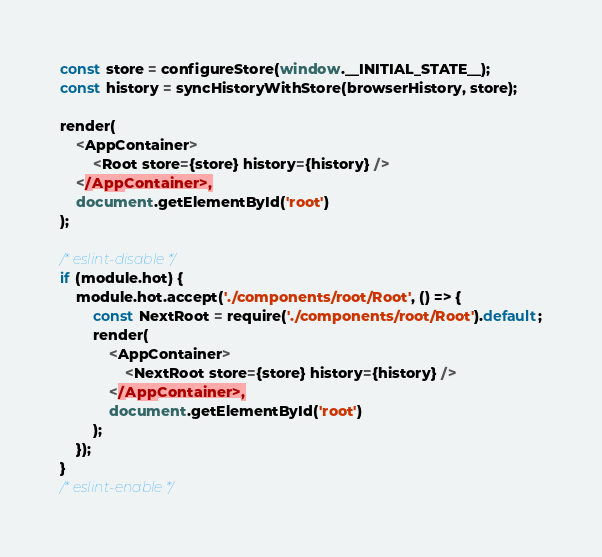Convert code to text. <code><loc_0><loc_0><loc_500><loc_500><_JavaScript_>const store = configureStore(window.__INITIAL_STATE__);
const history = syncHistoryWithStore(browserHistory, store);

render(
    <AppContainer>
        <Root store={store} history={history} />
    </AppContainer>,
    document.getElementById('root')
);

/* eslint-disable */
if (module.hot) {
    module.hot.accept('./components/root/Root', () => {
        const NextRoot = require('./components/root/Root').default;
        render(
            <AppContainer>
                <NextRoot store={store} history={history} />
            </AppContainer>,
            document.getElementById('root')
        );
    });
}
/* eslint-enable */
</code> 